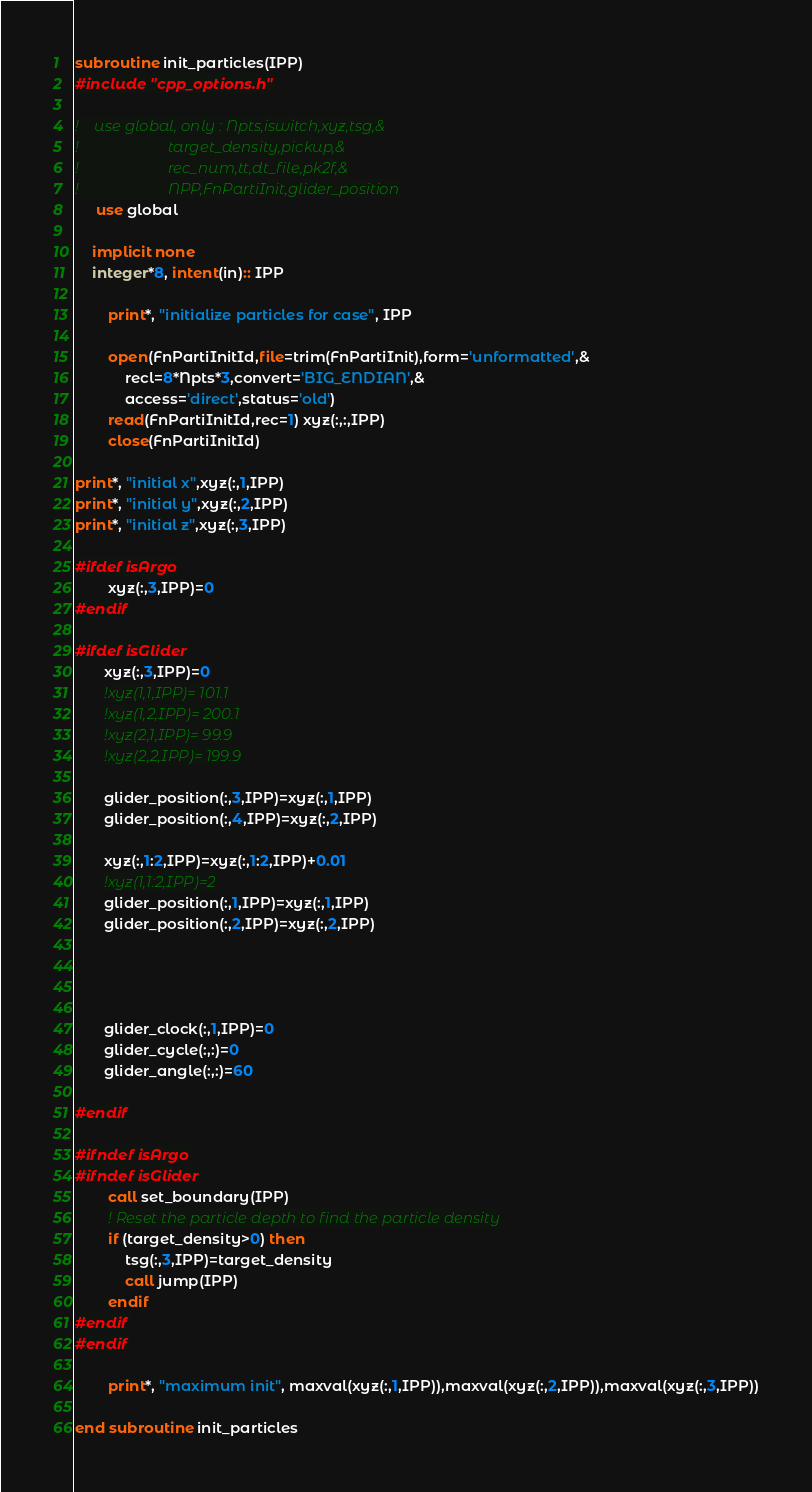Convert code to text. <code><loc_0><loc_0><loc_500><loc_500><_FORTRAN_>subroutine init_particles(IPP)
#include "cpp_options.h"

!    use global, only : Npts,iswitch,xyz,tsg,&
!                       target_density,pickup,&
!                       rec_num,tt,dt_file,pk2f,&
!                       NPP,FnPartiInit,glider_position
     use global

    implicit none
    integer*8, intent(in):: IPP

        print*, "initialize particles for case", IPP

        open(FnPartiInitId,file=trim(FnPartiInit),form='unformatted',&
            recl=8*Npts*3,convert='BIG_ENDIAN',&
            access='direct',status='old')
        read(FnPartiInitId,rec=1) xyz(:,:,IPP)
        close(FnPartiInitId)

print*, "initial x",xyz(:,1,IPP)
print*, "initial y",xyz(:,2,IPP)
print*, "initial z",xyz(:,3,IPP)

#ifdef isArgo
        xyz(:,3,IPP)=0
#endif

#ifdef isGlider
       xyz(:,3,IPP)=0
       !xyz(1,1,IPP)= 101.1
       !xyz(1,2,IPP)= 200.1
       !xyz(2,1,IPP)= 99.9
       !xyz(2,2,IPP)= 199.9

       glider_position(:,3,IPP)=xyz(:,1,IPP)
       glider_position(:,4,IPP)=xyz(:,2,IPP)

       xyz(:,1:2,IPP)=xyz(:,1:2,IPP)+0.01
       !xyz(1,1:2,IPP)=2
       glider_position(:,1,IPP)=xyz(:,1,IPP)
       glider_position(:,2,IPP)=xyz(:,2,IPP)


       

       glider_clock(:,1,IPP)=0
       glider_cycle(:,:)=0
       glider_angle(:,:)=60

#endif

#ifndef isArgo
#ifndef isGlider
        call set_boundary(IPP)
        ! Reset the particle depth to find the particle density
        if (target_density>0) then
            tsg(:,3,IPP)=target_density
            call jump(IPP)
        endif
#endif
#endif

        print*, "maximum init", maxval(xyz(:,1,IPP)),maxval(xyz(:,2,IPP)),maxval(xyz(:,3,IPP))

end subroutine init_particles

</code> 